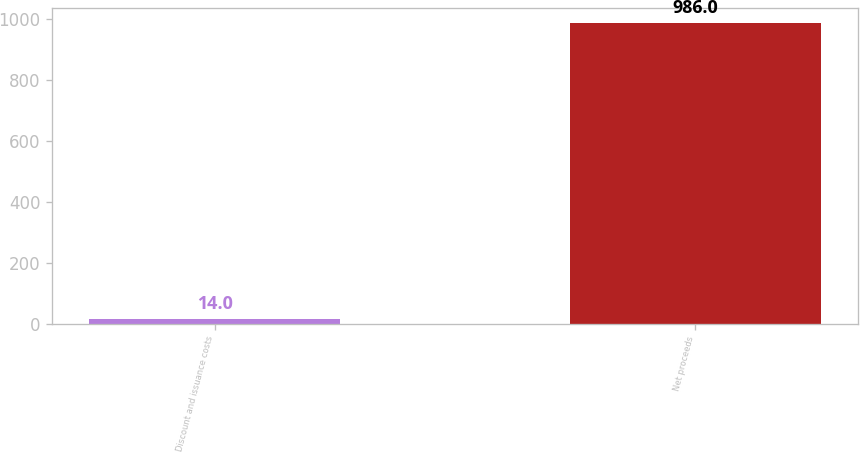<chart> <loc_0><loc_0><loc_500><loc_500><bar_chart><fcel>Discount and issuance costs<fcel>Net proceeds<nl><fcel>14<fcel>986<nl></chart> 